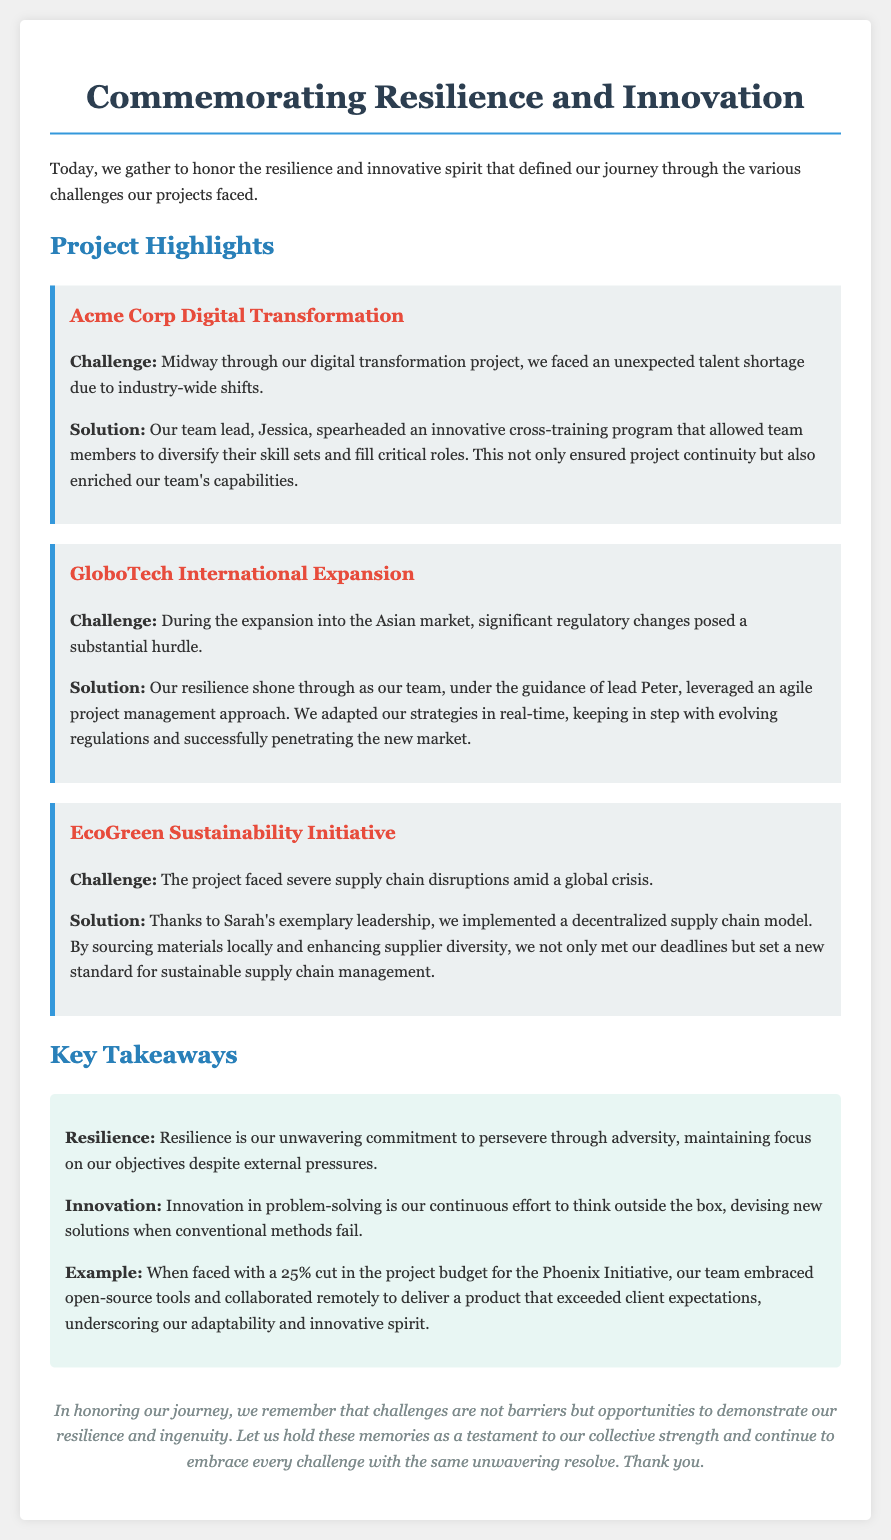what was the title of the document? The title is specified in the <title> tag of the document.
Answer: Commemorating Resilience and Innovation who was the team lead for the Acme Corp Digital Transformation project? The name of the team lead is mentioned in the project section of the document.
Answer: Jessica what was the challenge faced during the GloboTech International Expansion? The challenge is outlined in the project segment regarding GloboTech, focusing on regulatory changes.
Answer: Significant regulatory changes what innovative solution was implemented for the EcoGreen Sustainability Initiative? The solution is described in the EcoGreen project details.
Answer: Decentralized supply chain model what percentage budget cut did the Phoenix Initiative face? The percentage is mentioned in the key takeaway as part of the example.
Answer: 25% how did Peter's team adapt during the GloboTech project? The document states specific strategies employed during the project in response to challenges.
Answer: Agile project management approach what is the first key takeaway highlighted in the document? The key takeaways are listed under a specific section in the document.
Answer: Resilience what type of leadership did Sarah provide for the EcoGreen project? The type of leadership is characterized in the project section for EcoGreen.
Answer: Exemplary leadership what does the document ultimately suggest about challenges? The document concludes with reflections on the nature of challenges.
Answer: Opportunities to demonstrate resilience and ingenuity 